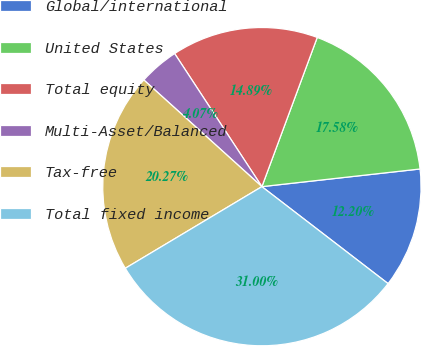<chart> <loc_0><loc_0><loc_500><loc_500><pie_chart><fcel>Global/international<fcel>United States<fcel>Total equity<fcel>Multi-Asset/Balanced<fcel>Tax-free<fcel>Total fixed income<nl><fcel>12.2%<fcel>17.58%<fcel>14.89%<fcel>4.07%<fcel>20.27%<fcel>31.0%<nl></chart> 